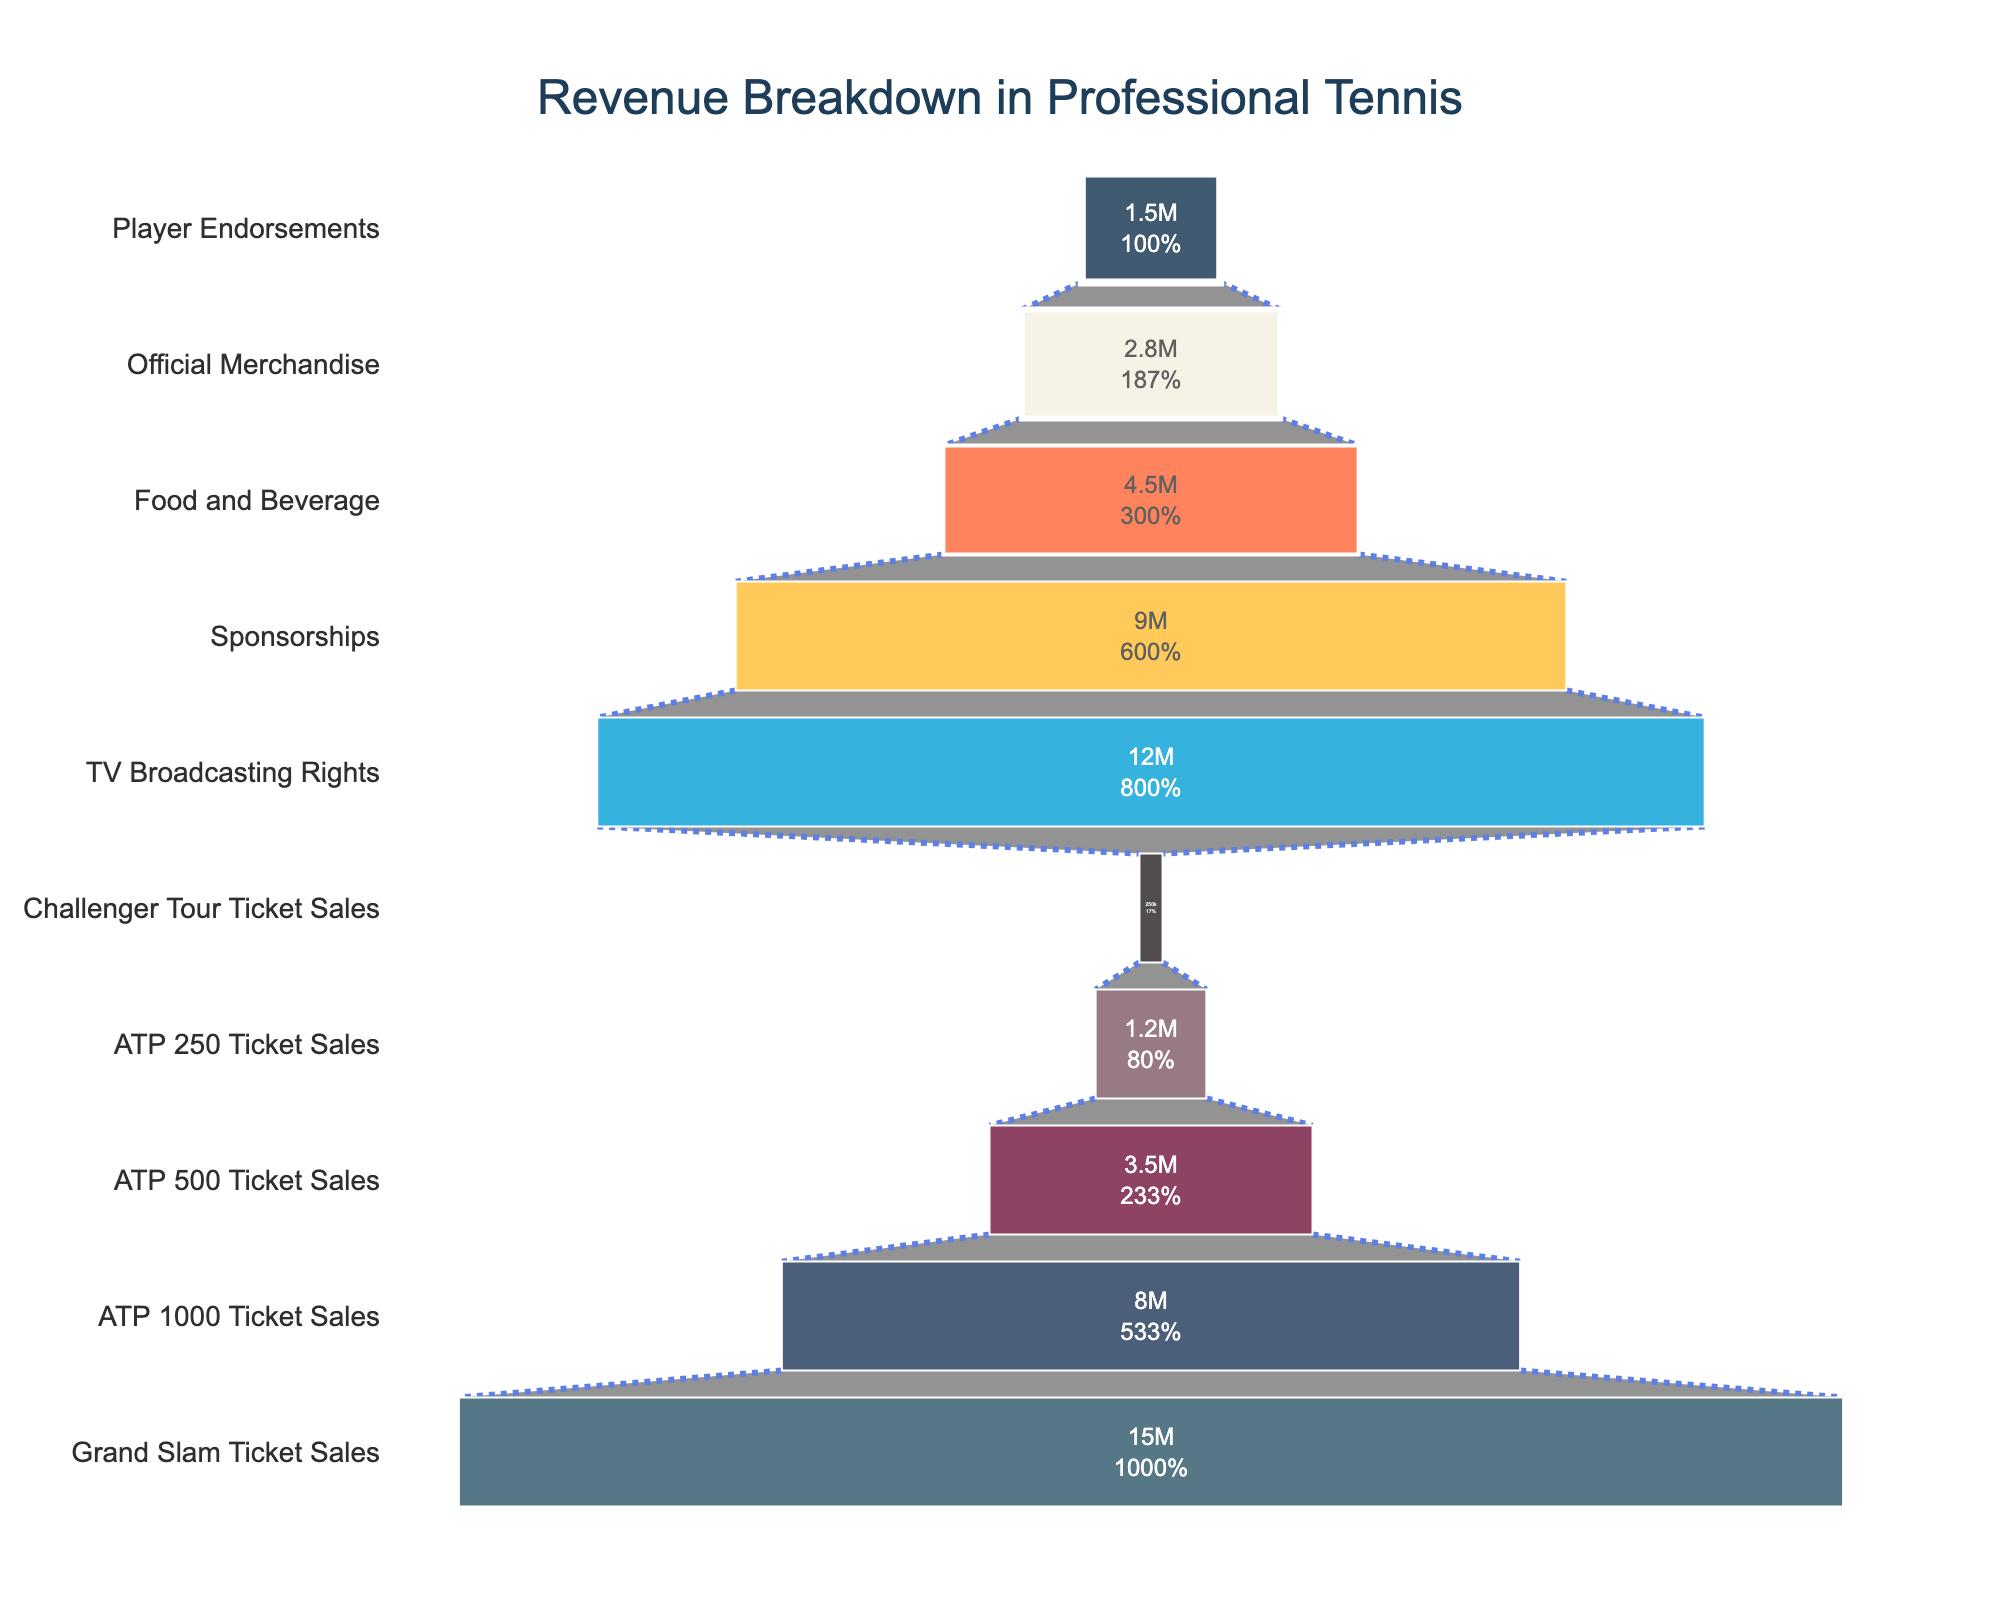What is the highest revenue source according to the figure? The highest bar in the funnel chart corresponds to the "Grand Slam Ticket Sales" stage, represented at the top of the funnel, which indicates the highest revenue.
Answer: Grand Slam Ticket Sales How much revenue comes from Sponsorships? The "Sponsorships" stage shows its revenue portion in the funnel. The label inside the bar indicates the revenue figure.
Answer: 9,000,000 EUR Which revenue stream has the lowest revenue? The smallest bar at the bottom of the funnel represents the "Challenger Tour Ticket Sales" stage, indicating the lowest revenue.
Answer: Challenger Tour Ticket Sales What percentage of total revenue is from TV Broadcasting Rights? Locate the "TV Broadcasting Rights" stage in the funnel. The label inside it should show the percentage of the total revenue.
Answer: Approximately 20% How much more revenue do Grand Slam Ticket Sales generate compared to ATP 250 Ticket Sales? Subtract the revenue of "ATP 250 Ticket Sales" from that of "Grand Slam Ticket Sales" by referring to their respective values in the funnel chart.
Answer: 13,800,000 EUR What stage comes immediately before Player Endorsements in the revenue breakdown? Identify the stage directly above the "Player Endorsements" stage in the funnel.
Answer: Official Merchandise How many different revenue stages are shown in the figure? Count the individual stages or bars in the funnel chart.
Answer: 10 stages Are the ATP 500 Ticket Sales higher or lower than the ATP 1000 Ticket Sales? Compare the heights of the bars or values for "ATP 500 Ticket Sales" and "ATP 1000 Ticket Sales".
Answer: Lower What is the combined revenue from Food and Beverage and Official Merchandise? Add the revenue values from both "Food and Beverage" and "Official Merchandise" stages as indicated on the funnel chart.
Answer: 7,300,000 EUR What is the difference between the revenue from ATP 1000 Ticket Sales and Challenger Tour Ticket Sales? Subtract the revenue of "Challenger Tour Ticket Sales" from "ATP 1000 Ticket Sales" by referring to their respective values in the funnel chart.
Answer: 7,750,000 EUR 